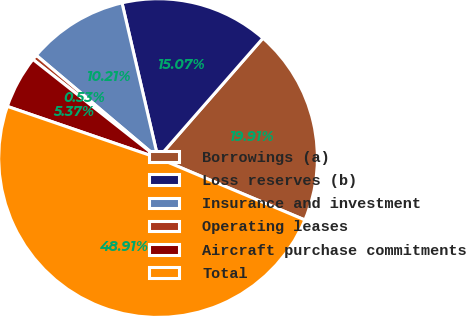<chart> <loc_0><loc_0><loc_500><loc_500><pie_chart><fcel>Borrowings (a)<fcel>Loss reserves (b)<fcel>Insurance and investment<fcel>Operating leases<fcel>Aircraft purchase commitments<fcel>Total<nl><fcel>19.91%<fcel>15.07%<fcel>10.21%<fcel>0.53%<fcel>5.37%<fcel>48.91%<nl></chart> 